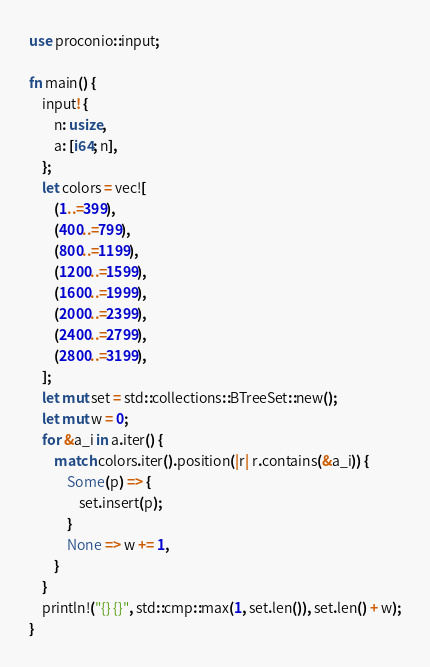Convert code to text. <code><loc_0><loc_0><loc_500><loc_500><_Rust_>use proconio::input;

fn main() {
    input! {
        n: usize,
        a: [i64; n],
    };
    let colors = vec![
        (1..=399),
        (400..=799),
        (800..=1199),
        (1200..=1599),
        (1600..=1999),
        (2000..=2399),
        (2400..=2799),
        (2800..=3199),
    ];
    let mut set = std::collections::BTreeSet::new();
    let mut w = 0;
    for &a_i in a.iter() {
        match colors.iter().position(|r| r.contains(&a_i)) {
            Some(p) => {
                set.insert(p);
            }
            None => w += 1,
        }
    }
    println!("{} {}", std::cmp::max(1, set.len()), set.len() + w);
}
</code> 